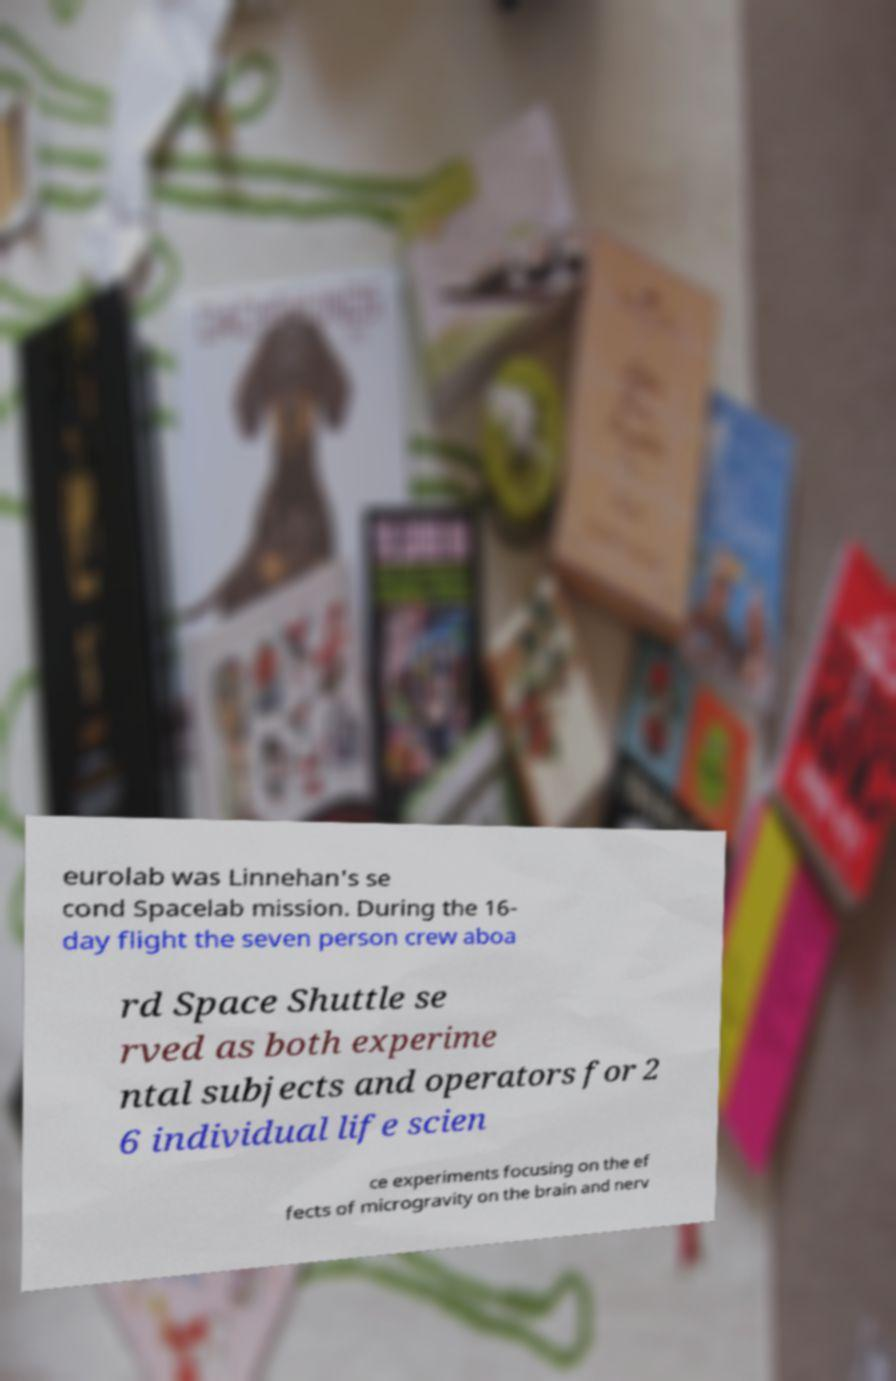Could you assist in decoding the text presented in this image and type it out clearly? eurolab was Linnehan's se cond Spacelab mission. During the 16- day flight the seven person crew aboa rd Space Shuttle se rved as both experime ntal subjects and operators for 2 6 individual life scien ce experiments focusing on the ef fects of microgravity on the brain and nerv 